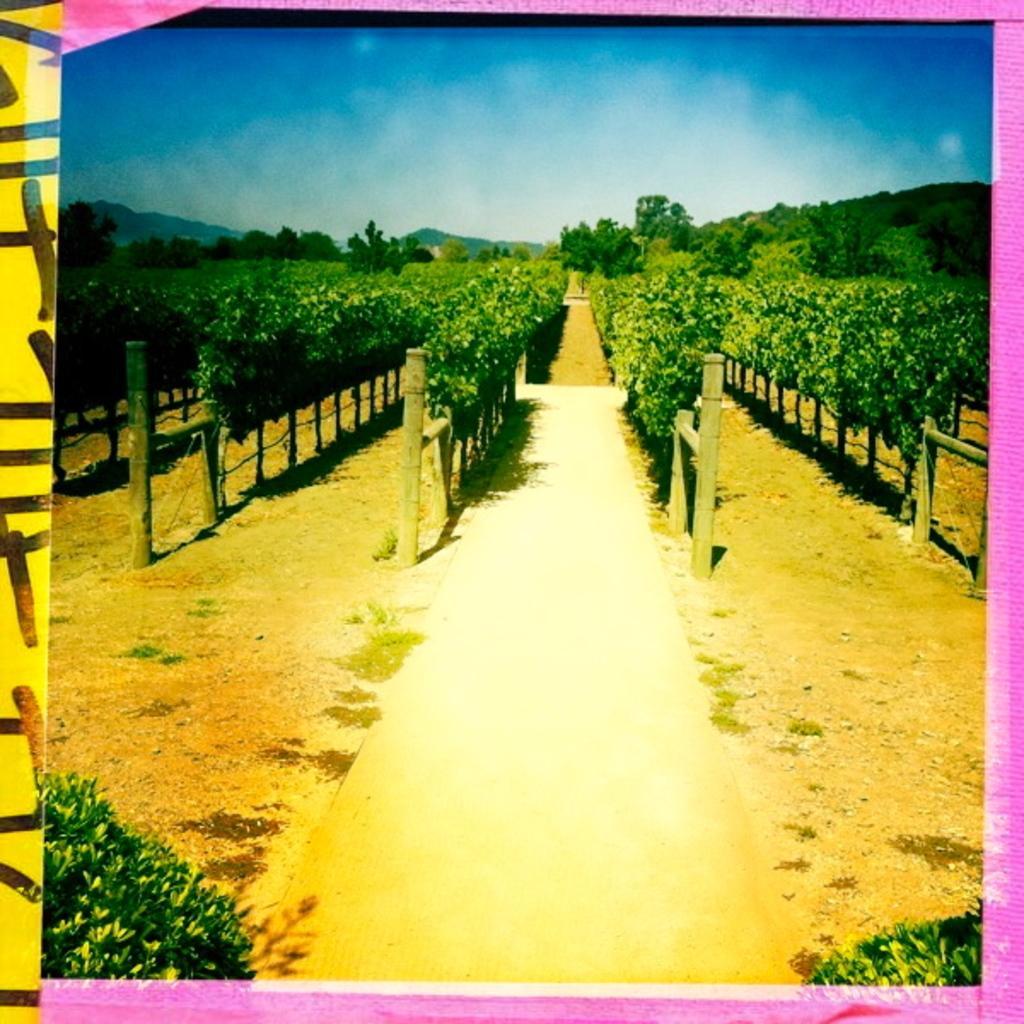Could you give a brief overview of what you see in this image? In this picture we can see some trees, at the bottom there are two plants, we can see the sky at the top of the picture. 